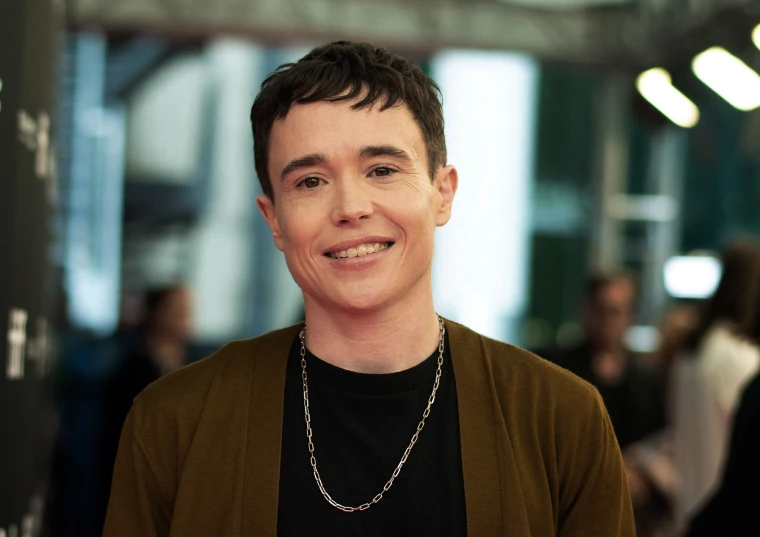What if this person just received some great news? What could it be? If this person just received some great news, it could be anything from being cast in a significant role in a movie, winning an award, or achieving a personal milestone they've been working towards. Their joyful expression and bright smile indicate that whatever the news is, it has brought immense happiness and a sense of accomplishment. 